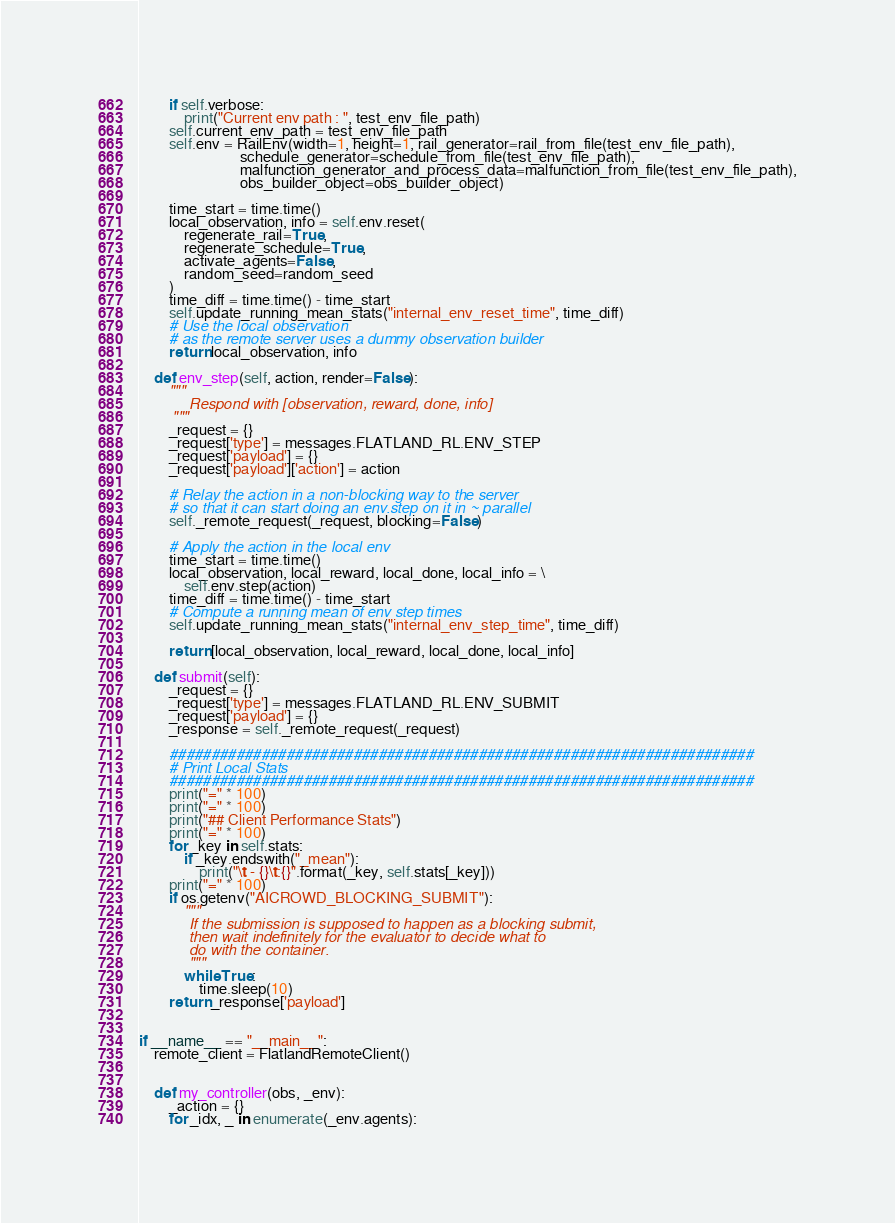Convert code to text. <code><loc_0><loc_0><loc_500><loc_500><_Python_>        if self.verbose:
            print("Current env path : ", test_env_file_path)
        self.current_env_path = test_env_file_path
        self.env = RailEnv(width=1, height=1, rail_generator=rail_from_file(test_env_file_path),
                           schedule_generator=schedule_from_file(test_env_file_path),
                           malfunction_generator_and_process_data=malfunction_from_file(test_env_file_path),
                           obs_builder_object=obs_builder_object)

        time_start = time.time()
        local_observation, info = self.env.reset(
            regenerate_rail=True,
            regenerate_schedule=True,
            activate_agents=False,
            random_seed=random_seed
        )
        time_diff = time.time() - time_start
        self.update_running_mean_stats("internal_env_reset_time", time_diff)
        # Use the local observation
        # as the remote server uses a dummy observation builder
        return local_observation, info

    def env_step(self, action, render=False):
        """
            Respond with [observation, reward, done, info]
        """
        _request = {}
        _request['type'] = messages.FLATLAND_RL.ENV_STEP
        _request['payload'] = {}
        _request['payload']['action'] = action

        # Relay the action in a non-blocking way to the server
        # so that it can start doing an env.step on it in ~ parallel
        self._remote_request(_request, blocking=False)

        # Apply the action in the local env
        time_start = time.time()
        local_observation, local_reward, local_done, local_info = \
            self.env.step(action)
        time_diff = time.time() - time_start
        # Compute a running mean of env step times
        self.update_running_mean_stats("internal_env_step_time", time_diff)

        return [local_observation, local_reward, local_done, local_info]

    def submit(self):
        _request = {}
        _request['type'] = messages.FLATLAND_RL.ENV_SUBMIT
        _request['payload'] = {}
        _response = self._remote_request(_request)

        ######################################################################
        # Print Local Stats
        ######################################################################
        print("=" * 100)
        print("=" * 100)
        print("## Client Performance Stats")
        print("=" * 100)
        for _key in self.stats:
            if _key.endswith("_mean"):
                print("\t - {}\t:{}".format(_key, self.stats[_key]))
        print("=" * 100)
        if os.getenv("AICROWD_BLOCKING_SUBMIT"):
            """
            If the submission is supposed to happen as a blocking submit,
            then wait indefinitely for the evaluator to decide what to 
            do with the container.
            """
            while True:
                time.sleep(10)
        return _response['payload']


if __name__ == "__main__":
    remote_client = FlatlandRemoteClient()


    def my_controller(obs, _env):
        _action = {}
        for _idx, _ in enumerate(_env.agents):</code> 